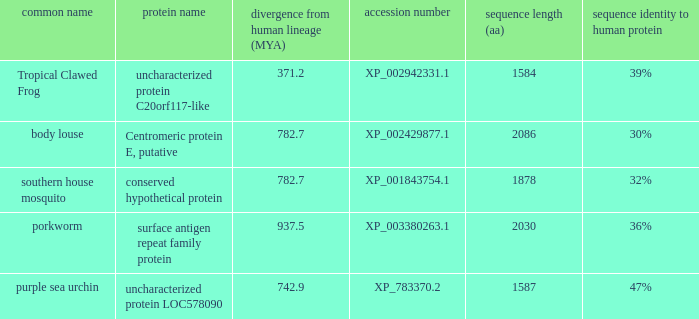What is the protein name of the protein with a sequence identity to human protein of 32%? Conserved hypothetical protein. 